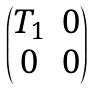<formula> <loc_0><loc_0><loc_500><loc_500>\begin{pmatrix} T _ { 1 } & 0 \\ 0 & 0 \end{pmatrix}</formula> 